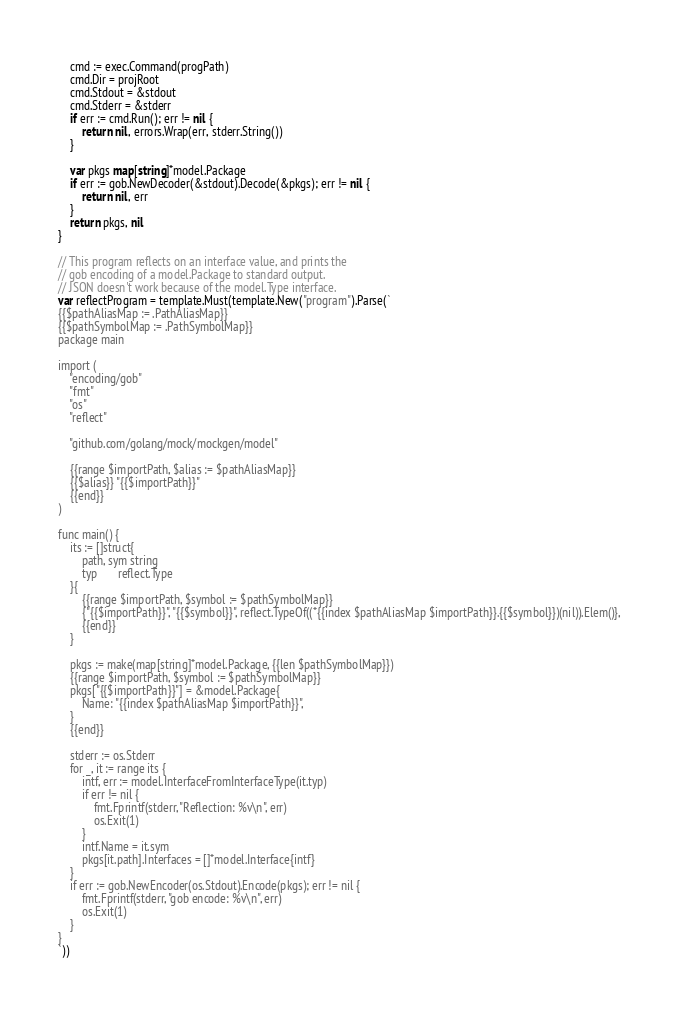<code> <loc_0><loc_0><loc_500><loc_500><_Go_>	cmd := exec.Command(progPath)
	cmd.Dir = projRoot
	cmd.Stdout = &stdout
	cmd.Stderr = &stderr
	if err := cmd.Run(); err != nil {
		return nil, errors.Wrap(err, stderr.String())
	}

	var pkgs map[string]*model.Package
	if err := gob.NewDecoder(&stdout).Decode(&pkgs); err != nil {
		return nil, err
	}
	return pkgs, nil
}

// This program reflects on an interface value, and prints the
// gob encoding of a model.Package to standard output.
// JSON doesn't work because of the model.Type interface.
var reflectProgram = template.Must(template.New("program").Parse(`
{{$pathAliasMap := .PathAliasMap}}
{{$pathSymbolMap := .PathSymbolMap}}
package main

import (
	"encoding/gob"
	"fmt"
	"os"
	"reflect"

	"github.com/golang/mock/mockgen/model"

	{{range $importPath, $alias := $pathAliasMap}}
	{{$alias}} "{{$importPath}}"
	{{end}}
)

func main() {
	its := []struct{
		path, sym string
		typ 	  reflect.Type
	}{
		{{range $importPath, $symbol := $pathSymbolMap}}
		{"{{$importPath}}", "{{$symbol}}", reflect.TypeOf((*{{index $pathAliasMap $importPath}}.{{$symbol}})(nil)).Elem()},
		{{end}}
	}

	pkgs := make(map[string]*model.Package, {{len $pathSymbolMap}})
	{{range $importPath, $symbol := $pathSymbolMap}}
	pkgs["{{$importPath}}"] = &model.Package{
		Name: "{{index $pathAliasMap $importPath}}",
	}
	{{end}}

	stderr := os.Stderr
	for _, it := range its {
		intf, err := model.InterfaceFromInterfaceType(it.typ)
		if err != nil {
			fmt.Fprintf(stderr, "Reflection: %v\n", err)
			os.Exit(1)
		}
		intf.Name = it.sym
		pkgs[it.path].Interfaces = []*model.Interface{intf}
	}
	if err := gob.NewEncoder(os.Stdout).Encode(pkgs); err != nil {
		fmt.Fprintf(stderr, "gob encode: %v\n", err)
		os.Exit(1)
	}
}
`))
</code> 